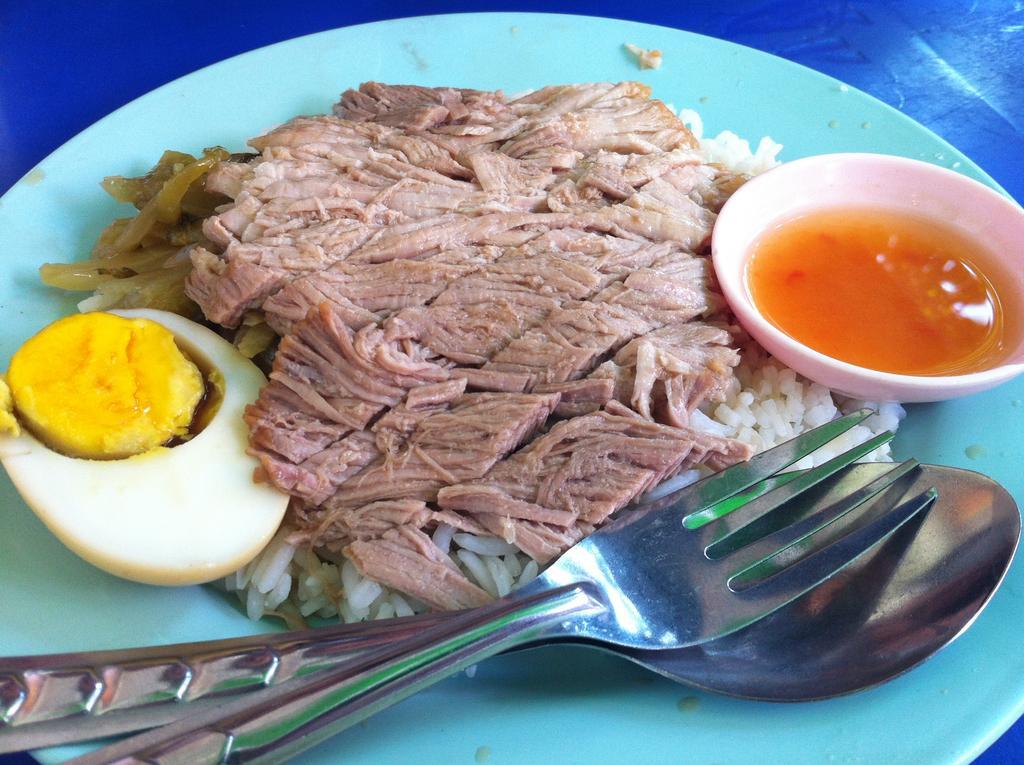Can you describe this image briefly? In this image there are some food items and a fork and a spoon on a plate, the plate is on top of a table. 